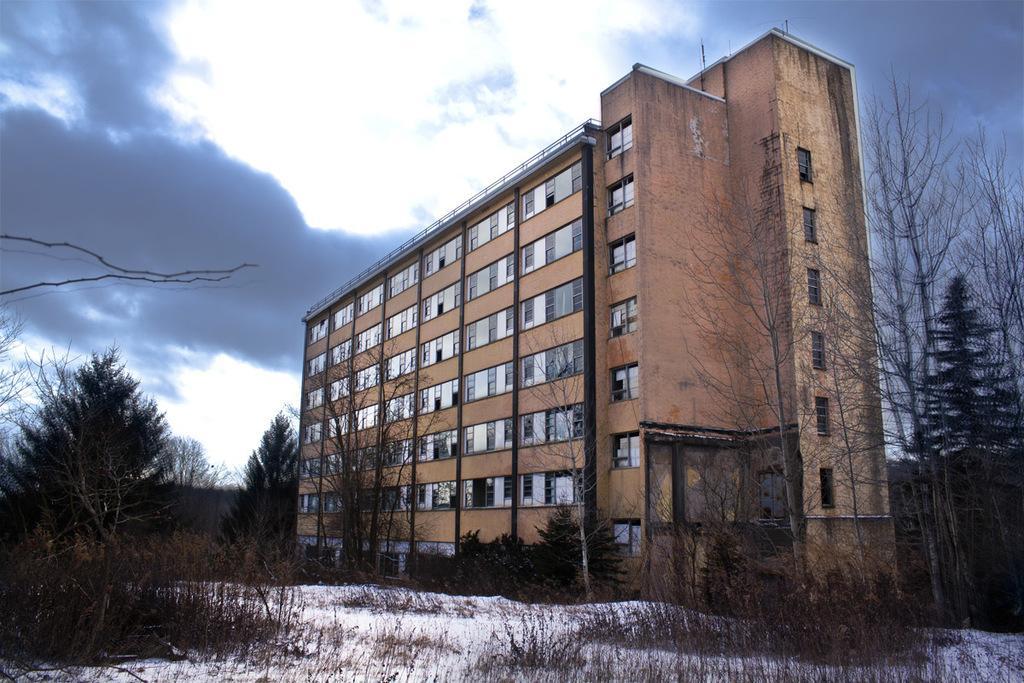Can you describe this image briefly? There are some trees as we can see at the bottom of this image, and there is a building in the middle of this image, and there is a cloudy sky at the top of this image. 